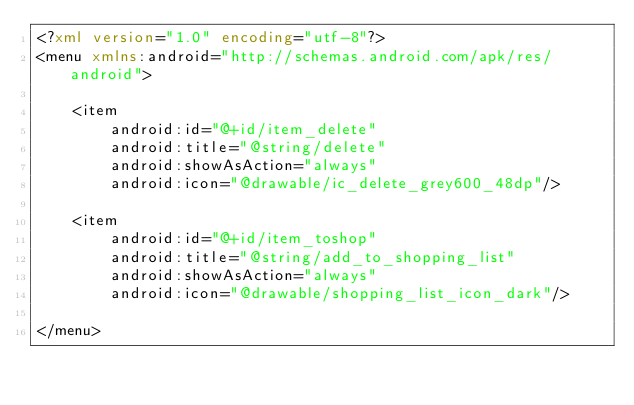<code> <loc_0><loc_0><loc_500><loc_500><_XML_><?xml version="1.0" encoding="utf-8"?>
<menu xmlns:android="http://schemas.android.com/apk/res/android">

    <item
        android:id="@+id/item_delete"
        android:title="@string/delete"
        android:showAsAction="always"
        android:icon="@drawable/ic_delete_grey600_48dp"/>

    <item
        android:id="@+id/item_toshop"
        android:title="@string/add_to_shopping_list"
        android:showAsAction="always"
        android:icon="@drawable/shopping_list_icon_dark"/>

</menu></code> 